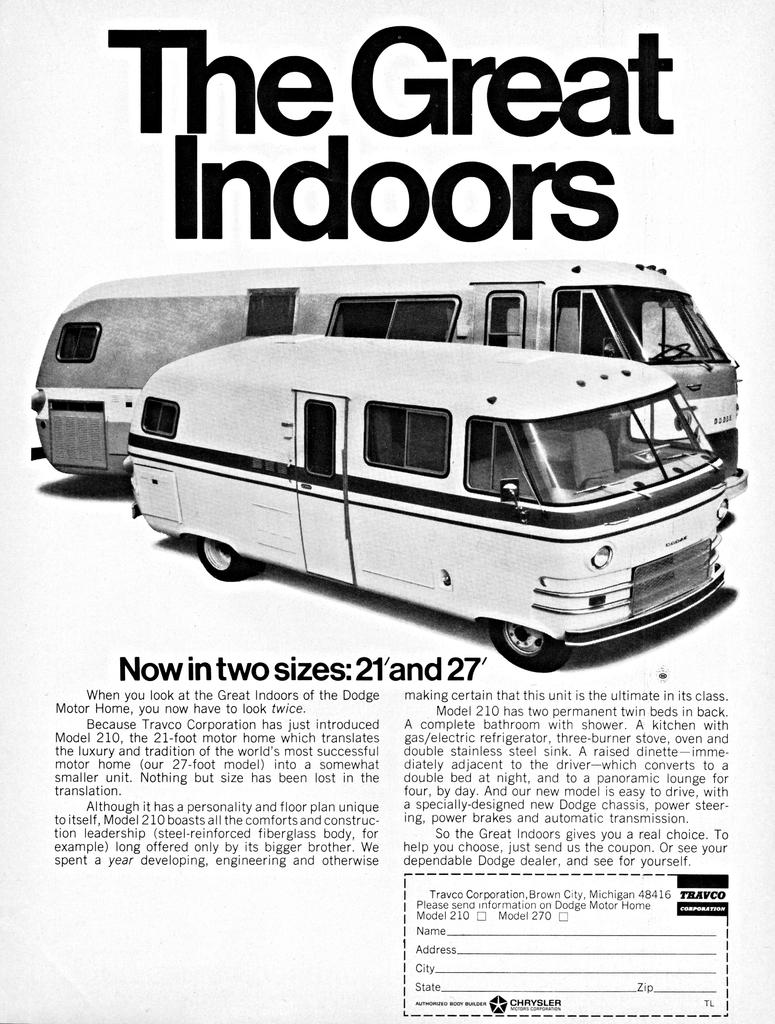<image>
Create a compact narrative representing the image presented. An old ad for motor homes says, "The Great Indoors" on the top. 